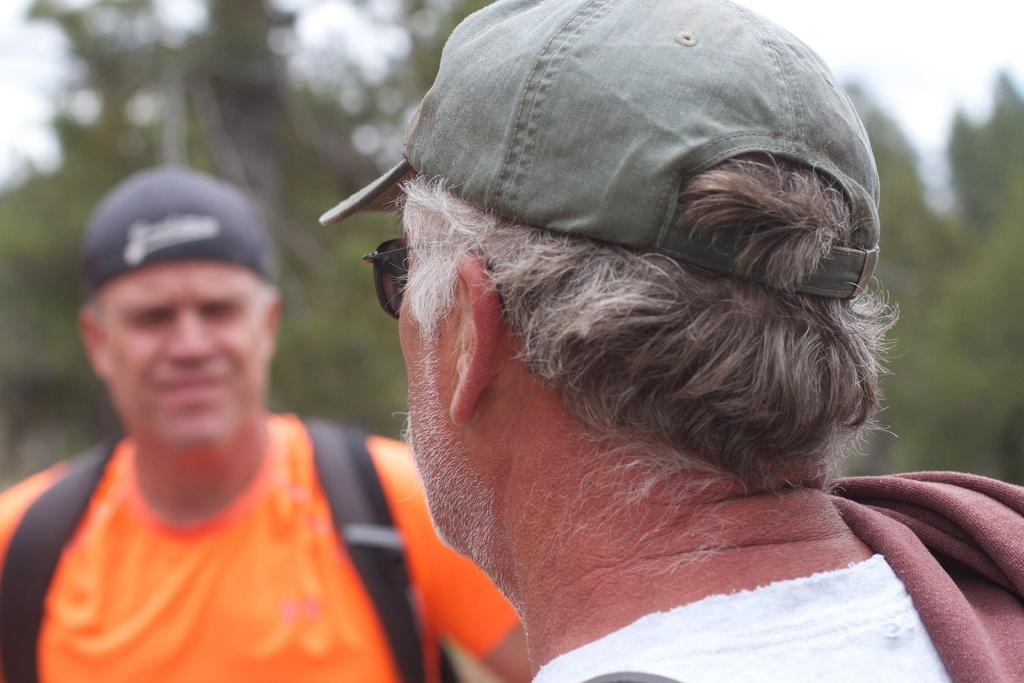How many people are in the image? There are persons in the image, but the exact number is not specified. What can be seen in the background of the image? There are trees and the sky visible in the background of the image. What type of tooth is visible in the image? There is no tooth present in the image. Who is giving the haircut in the image? There is no haircut being performed in the image. 